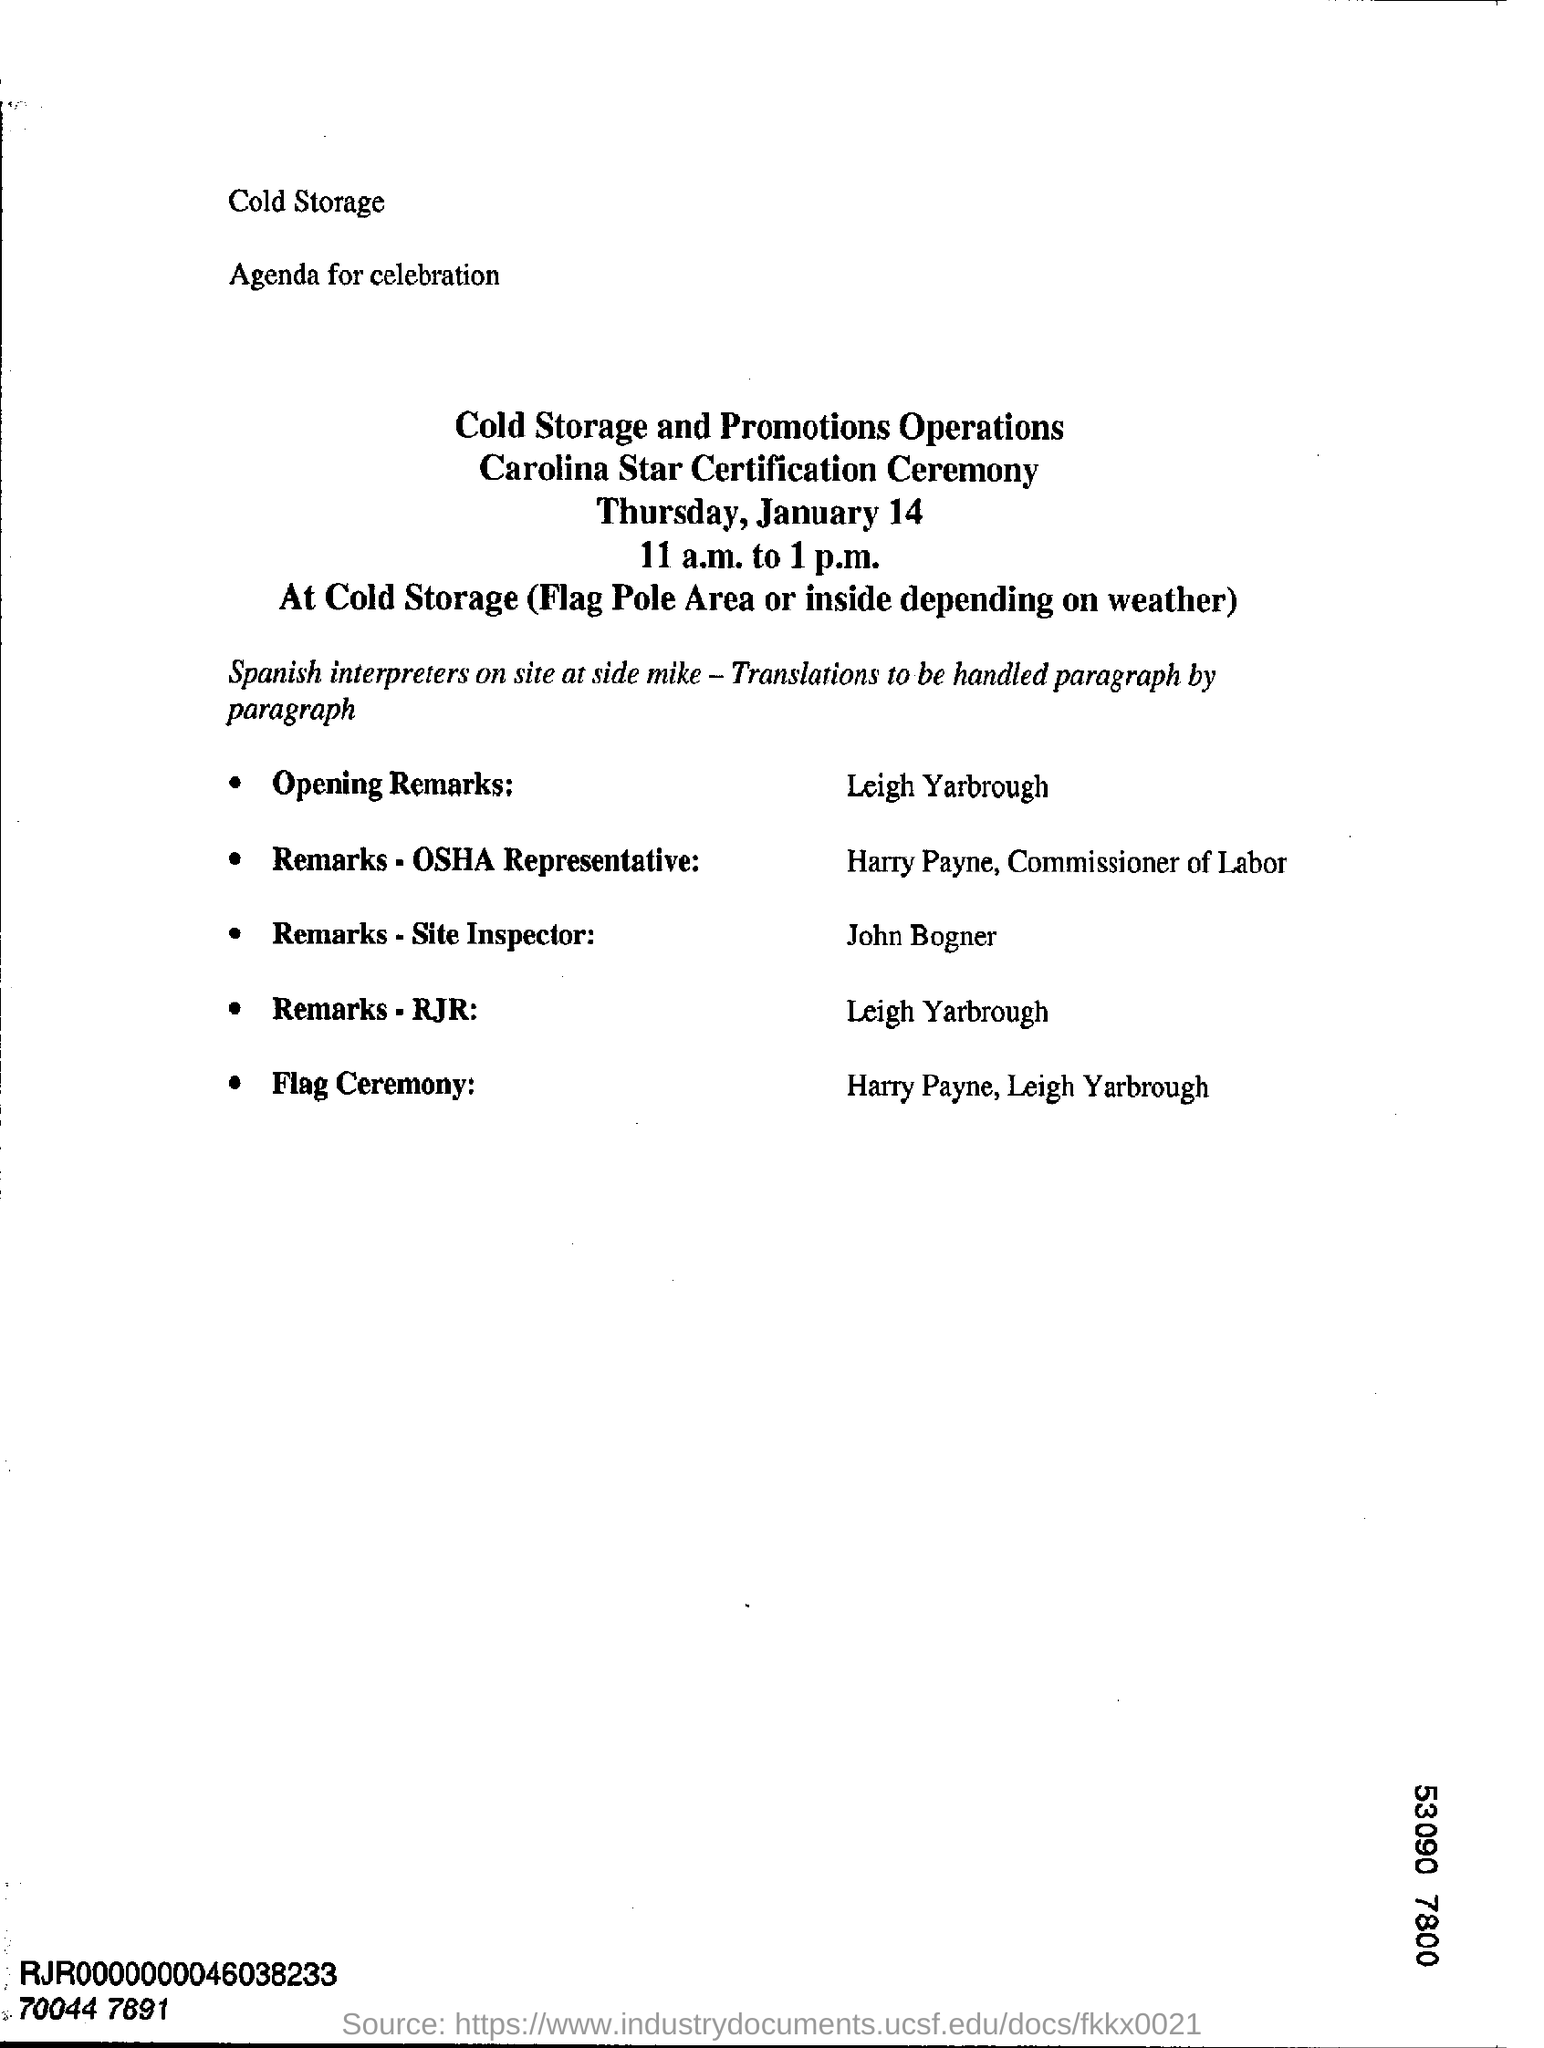Give some essential details in this illustration. The venue for the Carolina Star Certification Ceremony is Cold Storage, located at the Flag Pole Area or inside depending on the weather. It has been announced that Leigh Yarbrough will be delivering the opening remarks. On January 14, Thursday was the day of the week. 